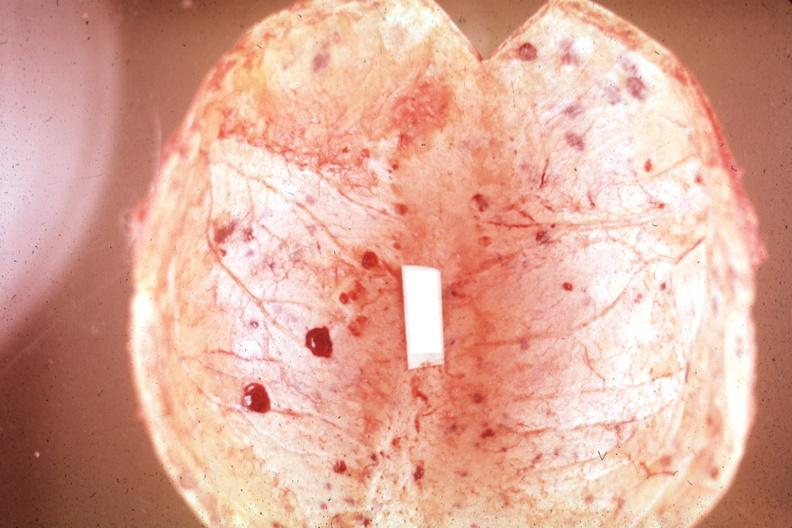re multiple and typical lesions easily seen?
Answer the question using a single word or phrase. Yes 